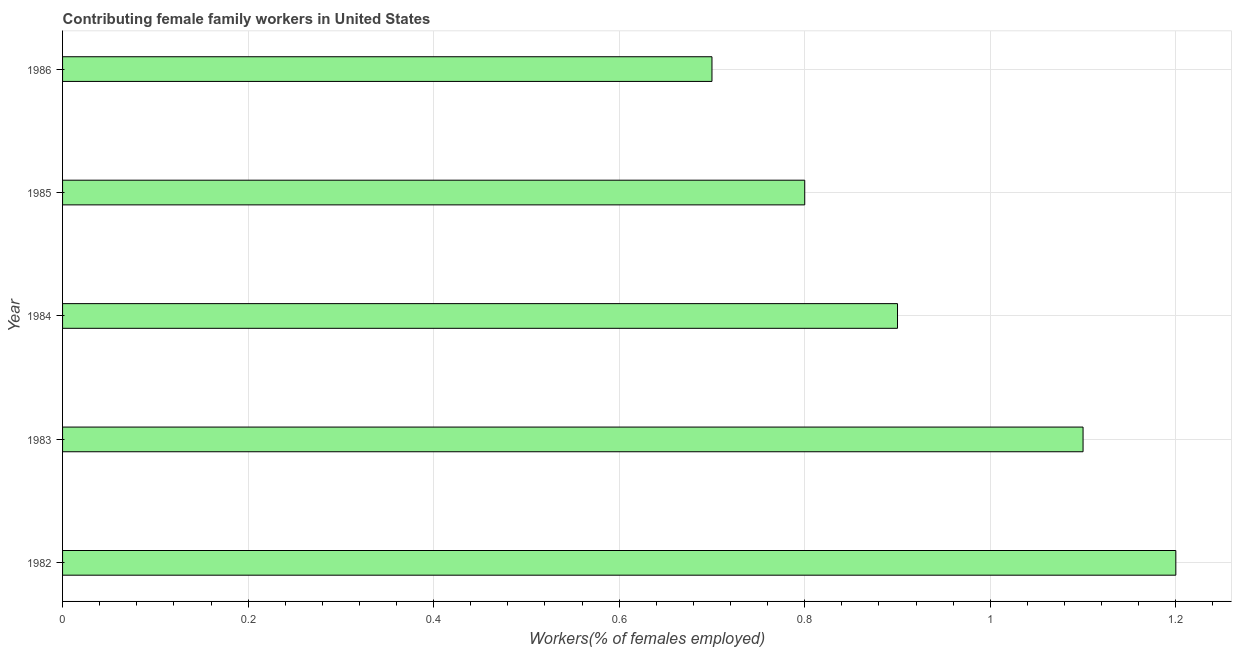Does the graph contain any zero values?
Offer a terse response. No. Does the graph contain grids?
Offer a very short reply. Yes. What is the title of the graph?
Make the answer very short. Contributing female family workers in United States. What is the label or title of the X-axis?
Give a very brief answer. Workers(% of females employed). What is the contributing female family workers in 1982?
Offer a terse response. 1.2. Across all years, what is the maximum contributing female family workers?
Give a very brief answer. 1.2. Across all years, what is the minimum contributing female family workers?
Provide a succinct answer. 0.7. What is the sum of the contributing female family workers?
Your answer should be compact. 4.7. What is the difference between the contributing female family workers in 1982 and 1986?
Your answer should be very brief. 0.5. What is the median contributing female family workers?
Ensure brevity in your answer.  0.9. What is the ratio of the contributing female family workers in 1982 to that in 1983?
Your response must be concise. 1.09. Is the sum of the contributing female family workers in 1984 and 1985 greater than the maximum contributing female family workers across all years?
Make the answer very short. Yes. Are all the bars in the graph horizontal?
Offer a very short reply. Yes. How many years are there in the graph?
Provide a succinct answer. 5. What is the Workers(% of females employed) of 1982?
Provide a short and direct response. 1.2. What is the Workers(% of females employed) in 1983?
Provide a succinct answer. 1.1. What is the Workers(% of females employed) of 1984?
Your response must be concise. 0.9. What is the Workers(% of females employed) of 1985?
Provide a succinct answer. 0.8. What is the Workers(% of females employed) in 1986?
Ensure brevity in your answer.  0.7. What is the difference between the Workers(% of females employed) in 1982 and 1985?
Your response must be concise. 0.4. What is the difference between the Workers(% of females employed) in 1983 and 1986?
Offer a very short reply. 0.4. What is the ratio of the Workers(% of females employed) in 1982 to that in 1983?
Ensure brevity in your answer.  1.09. What is the ratio of the Workers(% of females employed) in 1982 to that in 1984?
Offer a terse response. 1.33. What is the ratio of the Workers(% of females employed) in 1982 to that in 1985?
Give a very brief answer. 1.5. What is the ratio of the Workers(% of females employed) in 1982 to that in 1986?
Your response must be concise. 1.71. What is the ratio of the Workers(% of females employed) in 1983 to that in 1984?
Give a very brief answer. 1.22. What is the ratio of the Workers(% of females employed) in 1983 to that in 1985?
Offer a terse response. 1.38. What is the ratio of the Workers(% of females employed) in 1983 to that in 1986?
Offer a terse response. 1.57. What is the ratio of the Workers(% of females employed) in 1984 to that in 1986?
Offer a terse response. 1.29. What is the ratio of the Workers(% of females employed) in 1985 to that in 1986?
Offer a very short reply. 1.14. 